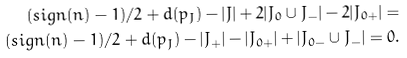<formula> <loc_0><loc_0><loc_500><loc_500>{ ( s i g n ( n ) - 1 ) / 2 + d ( p _ { J } ) - | J | + 2 | J _ { 0 } \cup J _ { - } | } - 2 | J _ { 0 + } | = \\ { ( s i g n ( n ) - 1 ) / 2 + d ( p _ { J } ) - | J _ { + } | - | J _ { 0 + } | + | J _ { 0 - } \cup J _ { - } | } = 0 .</formula> 